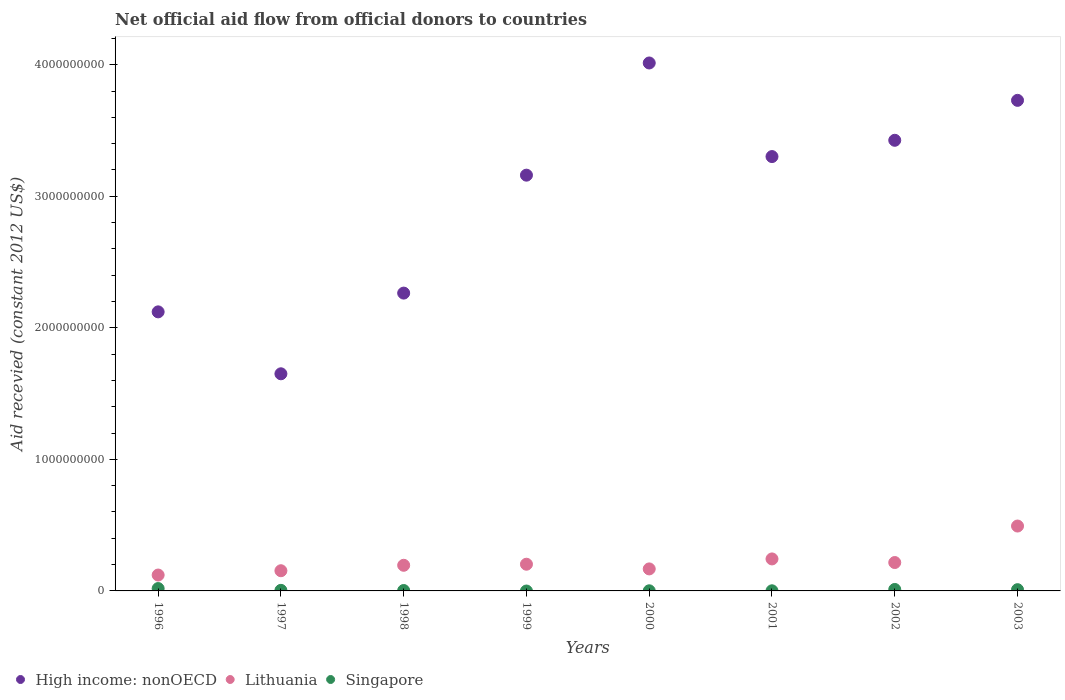Is the number of dotlines equal to the number of legend labels?
Provide a short and direct response. No. What is the total aid received in High income: nonOECD in 1997?
Ensure brevity in your answer.  1.65e+09. Across all years, what is the maximum total aid received in High income: nonOECD?
Your answer should be very brief. 4.01e+09. What is the total total aid received in Singapore in the graph?
Give a very brief answer. 4.79e+07. What is the difference between the total aid received in High income: nonOECD in 2001 and that in 2003?
Keep it short and to the point. -4.27e+08. What is the difference between the total aid received in High income: nonOECD in 2002 and the total aid received in Lithuania in 1996?
Provide a short and direct response. 3.30e+09. What is the average total aid received in High income: nonOECD per year?
Provide a succinct answer. 2.96e+09. In the year 2003, what is the difference between the total aid received in Singapore and total aid received in High income: nonOECD?
Your answer should be compact. -3.72e+09. What is the ratio of the total aid received in Singapore in 1997 to that in 1998?
Provide a succinct answer. 1.44. What is the difference between the highest and the second highest total aid received in Singapore?
Make the answer very short. 6.95e+06. What is the difference between the highest and the lowest total aid received in Singapore?
Keep it short and to the point. 1.80e+07. In how many years, is the total aid received in Singapore greater than the average total aid received in Singapore taken over all years?
Offer a very short reply. 3. Is it the case that in every year, the sum of the total aid received in Singapore and total aid received in Lithuania  is greater than the total aid received in High income: nonOECD?
Provide a short and direct response. No. Does the total aid received in Lithuania monotonically increase over the years?
Make the answer very short. No. Is the total aid received in Singapore strictly greater than the total aid received in Lithuania over the years?
Make the answer very short. No. Is the total aid received in Lithuania strictly less than the total aid received in Singapore over the years?
Provide a succinct answer. No. How many dotlines are there?
Ensure brevity in your answer.  3. How many years are there in the graph?
Offer a terse response. 8. What is the difference between two consecutive major ticks on the Y-axis?
Provide a short and direct response. 1.00e+09. Are the values on the major ticks of Y-axis written in scientific E-notation?
Offer a terse response. No. Does the graph contain grids?
Ensure brevity in your answer.  No. How are the legend labels stacked?
Your answer should be compact. Horizontal. What is the title of the graph?
Keep it short and to the point. Net official aid flow from official donors to countries. Does "Vanuatu" appear as one of the legend labels in the graph?
Offer a very short reply. No. What is the label or title of the X-axis?
Your answer should be compact. Years. What is the label or title of the Y-axis?
Ensure brevity in your answer.  Aid recevied (constant 2012 US$). What is the Aid recevied (constant 2012 US$) in High income: nonOECD in 1996?
Offer a very short reply. 2.12e+09. What is the Aid recevied (constant 2012 US$) in Lithuania in 1996?
Your response must be concise. 1.21e+08. What is the Aid recevied (constant 2012 US$) of Singapore in 1996?
Provide a short and direct response. 1.80e+07. What is the Aid recevied (constant 2012 US$) of High income: nonOECD in 1997?
Keep it short and to the point. 1.65e+09. What is the Aid recevied (constant 2012 US$) of Lithuania in 1997?
Provide a short and direct response. 1.53e+08. What is the Aid recevied (constant 2012 US$) of Singapore in 1997?
Provide a succinct answer. 4.37e+06. What is the Aid recevied (constant 2012 US$) of High income: nonOECD in 1998?
Provide a succinct answer. 2.26e+09. What is the Aid recevied (constant 2012 US$) in Lithuania in 1998?
Keep it short and to the point. 1.95e+08. What is the Aid recevied (constant 2012 US$) of Singapore in 1998?
Ensure brevity in your answer.  3.04e+06. What is the Aid recevied (constant 2012 US$) of High income: nonOECD in 1999?
Keep it short and to the point. 3.16e+09. What is the Aid recevied (constant 2012 US$) in Lithuania in 1999?
Provide a succinct answer. 2.03e+08. What is the Aid recevied (constant 2012 US$) in High income: nonOECD in 2000?
Provide a succinct answer. 4.01e+09. What is the Aid recevied (constant 2012 US$) in Lithuania in 2000?
Ensure brevity in your answer.  1.67e+08. What is the Aid recevied (constant 2012 US$) of Singapore in 2000?
Keep it short and to the point. 9.80e+05. What is the Aid recevied (constant 2012 US$) in High income: nonOECD in 2001?
Your answer should be very brief. 3.30e+09. What is the Aid recevied (constant 2012 US$) of Lithuania in 2001?
Provide a succinct answer. 2.43e+08. What is the Aid recevied (constant 2012 US$) of Singapore in 2001?
Keep it short and to the point. 9.60e+05. What is the Aid recevied (constant 2012 US$) in High income: nonOECD in 2002?
Make the answer very short. 3.43e+09. What is the Aid recevied (constant 2012 US$) in Lithuania in 2002?
Offer a terse response. 2.16e+08. What is the Aid recevied (constant 2012 US$) in Singapore in 2002?
Ensure brevity in your answer.  1.11e+07. What is the Aid recevied (constant 2012 US$) of High income: nonOECD in 2003?
Offer a very short reply. 3.73e+09. What is the Aid recevied (constant 2012 US$) in Lithuania in 2003?
Ensure brevity in your answer.  4.93e+08. What is the Aid recevied (constant 2012 US$) in Singapore in 2003?
Give a very brief answer. 9.44e+06. Across all years, what is the maximum Aid recevied (constant 2012 US$) of High income: nonOECD?
Provide a short and direct response. 4.01e+09. Across all years, what is the maximum Aid recevied (constant 2012 US$) in Lithuania?
Offer a terse response. 4.93e+08. Across all years, what is the maximum Aid recevied (constant 2012 US$) in Singapore?
Give a very brief answer. 1.80e+07. Across all years, what is the minimum Aid recevied (constant 2012 US$) of High income: nonOECD?
Your answer should be compact. 1.65e+09. Across all years, what is the minimum Aid recevied (constant 2012 US$) of Lithuania?
Your answer should be compact. 1.21e+08. What is the total Aid recevied (constant 2012 US$) in High income: nonOECD in the graph?
Give a very brief answer. 2.37e+1. What is the total Aid recevied (constant 2012 US$) of Lithuania in the graph?
Provide a succinct answer. 1.79e+09. What is the total Aid recevied (constant 2012 US$) of Singapore in the graph?
Make the answer very short. 4.79e+07. What is the difference between the Aid recevied (constant 2012 US$) of High income: nonOECD in 1996 and that in 1997?
Offer a very short reply. 4.71e+08. What is the difference between the Aid recevied (constant 2012 US$) in Lithuania in 1996 and that in 1997?
Provide a succinct answer. -3.27e+07. What is the difference between the Aid recevied (constant 2012 US$) of Singapore in 1996 and that in 1997?
Give a very brief answer. 1.36e+07. What is the difference between the Aid recevied (constant 2012 US$) of High income: nonOECD in 1996 and that in 1998?
Provide a short and direct response. -1.43e+08. What is the difference between the Aid recevied (constant 2012 US$) of Lithuania in 1996 and that in 1998?
Your response must be concise. -7.41e+07. What is the difference between the Aid recevied (constant 2012 US$) in Singapore in 1996 and that in 1998?
Make the answer very short. 1.50e+07. What is the difference between the Aid recevied (constant 2012 US$) of High income: nonOECD in 1996 and that in 1999?
Provide a short and direct response. -1.04e+09. What is the difference between the Aid recevied (constant 2012 US$) in Lithuania in 1996 and that in 1999?
Provide a succinct answer. -8.22e+07. What is the difference between the Aid recevied (constant 2012 US$) in High income: nonOECD in 1996 and that in 2000?
Ensure brevity in your answer.  -1.89e+09. What is the difference between the Aid recevied (constant 2012 US$) in Lithuania in 1996 and that in 2000?
Offer a terse response. -4.65e+07. What is the difference between the Aid recevied (constant 2012 US$) of Singapore in 1996 and that in 2000?
Provide a succinct answer. 1.70e+07. What is the difference between the Aid recevied (constant 2012 US$) in High income: nonOECD in 1996 and that in 2001?
Your answer should be very brief. -1.18e+09. What is the difference between the Aid recevied (constant 2012 US$) in Lithuania in 1996 and that in 2001?
Provide a succinct answer. -1.22e+08. What is the difference between the Aid recevied (constant 2012 US$) in Singapore in 1996 and that in 2001?
Keep it short and to the point. 1.71e+07. What is the difference between the Aid recevied (constant 2012 US$) of High income: nonOECD in 1996 and that in 2002?
Provide a succinct answer. -1.30e+09. What is the difference between the Aid recevied (constant 2012 US$) of Lithuania in 1996 and that in 2002?
Make the answer very short. -9.50e+07. What is the difference between the Aid recevied (constant 2012 US$) of Singapore in 1996 and that in 2002?
Your response must be concise. 6.95e+06. What is the difference between the Aid recevied (constant 2012 US$) in High income: nonOECD in 1996 and that in 2003?
Provide a succinct answer. -1.61e+09. What is the difference between the Aid recevied (constant 2012 US$) of Lithuania in 1996 and that in 2003?
Provide a succinct answer. -3.72e+08. What is the difference between the Aid recevied (constant 2012 US$) in Singapore in 1996 and that in 2003?
Offer a very short reply. 8.58e+06. What is the difference between the Aid recevied (constant 2012 US$) in High income: nonOECD in 1997 and that in 1998?
Provide a succinct answer. -6.13e+08. What is the difference between the Aid recevied (constant 2012 US$) of Lithuania in 1997 and that in 1998?
Keep it short and to the point. -4.14e+07. What is the difference between the Aid recevied (constant 2012 US$) of Singapore in 1997 and that in 1998?
Your answer should be very brief. 1.33e+06. What is the difference between the Aid recevied (constant 2012 US$) in High income: nonOECD in 1997 and that in 1999?
Your answer should be compact. -1.51e+09. What is the difference between the Aid recevied (constant 2012 US$) of Lithuania in 1997 and that in 1999?
Ensure brevity in your answer.  -4.95e+07. What is the difference between the Aid recevied (constant 2012 US$) in High income: nonOECD in 1997 and that in 2000?
Your answer should be compact. -2.36e+09. What is the difference between the Aid recevied (constant 2012 US$) of Lithuania in 1997 and that in 2000?
Your answer should be compact. -1.38e+07. What is the difference between the Aid recevied (constant 2012 US$) of Singapore in 1997 and that in 2000?
Your answer should be very brief. 3.39e+06. What is the difference between the Aid recevied (constant 2012 US$) of High income: nonOECD in 1997 and that in 2001?
Your answer should be compact. -1.65e+09. What is the difference between the Aid recevied (constant 2012 US$) in Lithuania in 1997 and that in 2001?
Make the answer very short. -8.98e+07. What is the difference between the Aid recevied (constant 2012 US$) in Singapore in 1997 and that in 2001?
Your response must be concise. 3.41e+06. What is the difference between the Aid recevied (constant 2012 US$) of High income: nonOECD in 1997 and that in 2002?
Give a very brief answer. -1.78e+09. What is the difference between the Aid recevied (constant 2012 US$) of Lithuania in 1997 and that in 2002?
Provide a succinct answer. -6.24e+07. What is the difference between the Aid recevied (constant 2012 US$) of Singapore in 1997 and that in 2002?
Give a very brief answer. -6.70e+06. What is the difference between the Aid recevied (constant 2012 US$) in High income: nonOECD in 1997 and that in 2003?
Provide a short and direct response. -2.08e+09. What is the difference between the Aid recevied (constant 2012 US$) of Lithuania in 1997 and that in 2003?
Offer a terse response. -3.40e+08. What is the difference between the Aid recevied (constant 2012 US$) in Singapore in 1997 and that in 2003?
Your answer should be very brief. -5.07e+06. What is the difference between the Aid recevied (constant 2012 US$) of High income: nonOECD in 1998 and that in 1999?
Your response must be concise. -8.97e+08. What is the difference between the Aid recevied (constant 2012 US$) in Lithuania in 1998 and that in 1999?
Provide a short and direct response. -8.09e+06. What is the difference between the Aid recevied (constant 2012 US$) of High income: nonOECD in 1998 and that in 2000?
Give a very brief answer. -1.75e+09. What is the difference between the Aid recevied (constant 2012 US$) of Lithuania in 1998 and that in 2000?
Make the answer very short. 2.76e+07. What is the difference between the Aid recevied (constant 2012 US$) of Singapore in 1998 and that in 2000?
Offer a very short reply. 2.06e+06. What is the difference between the Aid recevied (constant 2012 US$) of High income: nonOECD in 1998 and that in 2001?
Provide a short and direct response. -1.04e+09. What is the difference between the Aid recevied (constant 2012 US$) of Lithuania in 1998 and that in 2001?
Provide a succinct answer. -4.84e+07. What is the difference between the Aid recevied (constant 2012 US$) of Singapore in 1998 and that in 2001?
Your response must be concise. 2.08e+06. What is the difference between the Aid recevied (constant 2012 US$) of High income: nonOECD in 1998 and that in 2002?
Provide a short and direct response. -1.16e+09. What is the difference between the Aid recevied (constant 2012 US$) of Lithuania in 1998 and that in 2002?
Offer a very short reply. -2.10e+07. What is the difference between the Aid recevied (constant 2012 US$) of Singapore in 1998 and that in 2002?
Offer a very short reply. -8.03e+06. What is the difference between the Aid recevied (constant 2012 US$) in High income: nonOECD in 1998 and that in 2003?
Your response must be concise. -1.47e+09. What is the difference between the Aid recevied (constant 2012 US$) in Lithuania in 1998 and that in 2003?
Your answer should be very brief. -2.98e+08. What is the difference between the Aid recevied (constant 2012 US$) in Singapore in 1998 and that in 2003?
Your response must be concise. -6.40e+06. What is the difference between the Aid recevied (constant 2012 US$) in High income: nonOECD in 1999 and that in 2000?
Offer a terse response. -8.53e+08. What is the difference between the Aid recevied (constant 2012 US$) in Lithuania in 1999 and that in 2000?
Offer a terse response. 3.57e+07. What is the difference between the Aid recevied (constant 2012 US$) of High income: nonOECD in 1999 and that in 2001?
Give a very brief answer. -1.41e+08. What is the difference between the Aid recevied (constant 2012 US$) of Lithuania in 1999 and that in 2001?
Offer a terse response. -4.03e+07. What is the difference between the Aid recevied (constant 2012 US$) of High income: nonOECD in 1999 and that in 2002?
Keep it short and to the point. -2.65e+08. What is the difference between the Aid recevied (constant 2012 US$) in Lithuania in 1999 and that in 2002?
Give a very brief answer. -1.29e+07. What is the difference between the Aid recevied (constant 2012 US$) in High income: nonOECD in 1999 and that in 2003?
Make the answer very short. -5.69e+08. What is the difference between the Aid recevied (constant 2012 US$) of Lithuania in 1999 and that in 2003?
Provide a short and direct response. -2.90e+08. What is the difference between the Aid recevied (constant 2012 US$) of High income: nonOECD in 2000 and that in 2001?
Ensure brevity in your answer.  7.12e+08. What is the difference between the Aid recevied (constant 2012 US$) of Lithuania in 2000 and that in 2001?
Keep it short and to the point. -7.60e+07. What is the difference between the Aid recevied (constant 2012 US$) of Singapore in 2000 and that in 2001?
Provide a short and direct response. 2.00e+04. What is the difference between the Aid recevied (constant 2012 US$) of High income: nonOECD in 2000 and that in 2002?
Provide a succinct answer. 5.88e+08. What is the difference between the Aid recevied (constant 2012 US$) of Lithuania in 2000 and that in 2002?
Offer a very short reply. -4.85e+07. What is the difference between the Aid recevied (constant 2012 US$) in Singapore in 2000 and that in 2002?
Your answer should be compact. -1.01e+07. What is the difference between the Aid recevied (constant 2012 US$) in High income: nonOECD in 2000 and that in 2003?
Give a very brief answer. 2.84e+08. What is the difference between the Aid recevied (constant 2012 US$) in Lithuania in 2000 and that in 2003?
Your answer should be very brief. -3.26e+08. What is the difference between the Aid recevied (constant 2012 US$) in Singapore in 2000 and that in 2003?
Offer a very short reply. -8.46e+06. What is the difference between the Aid recevied (constant 2012 US$) of High income: nonOECD in 2001 and that in 2002?
Your answer should be compact. -1.24e+08. What is the difference between the Aid recevied (constant 2012 US$) of Lithuania in 2001 and that in 2002?
Give a very brief answer. 2.74e+07. What is the difference between the Aid recevied (constant 2012 US$) of Singapore in 2001 and that in 2002?
Provide a succinct answer. -1.01e+07. What is the difference between the Aid recevied (constant 2012 US$) in High income: nonOECD in 2001 and that in 2003?
Make the answer very short. -4.27e+08. What is the difference between the Aid recevied (constant 2012 US$) of Lithuania in 2001 and that in 2003?
Offer a terse response. -2.50e+08. What is the difference between the Aid recevied (constant 2012 US$) of Singapore in 2001 and that in 2003?
Your response must be concise. -8.48e+06. What is the difference between the Aid recevied (constant 2012 US$) in High income: nonOECD in 2002 and that in 2003?
Make the answer very short. -3.04e+08. What is the difference between the Aid recevied (constant 2012 US$) in Lithuania in 2002 and that in 2003?
Give a very brief answer. -2.77e+08. What is the difference between the Aid recevied (constant 2012 US$) of Singapore in 2002 and that in 2003?
Provide a short and direct response. 1.63e+06. What is the difference between the Aid recevied (constant 2012 US$) of High income: nonOECD in 1996 and the Aid recevied (constant 2012 US$) of Lithuania in 1997?
Your answer should be compact. 1.97e+09. What is the difference between the Aid recevied (constant 2012 US$) in High income: nonOECD in 1996 and the Aid recevied (constant 2012 US$) in Singapore in 1997?
Provide a succinct answer. 2.12e+09. What is the difference between the Aid recevied (constant 2012 US$) in Lithuania in 1996 and the Aid recevied (constant 2012 US$) in Singapore in 1997?
Your answer should be very brief. 1.16e+08. What is the difference between the Aid recevied (constant 2012 US$) of High income: nonOECD in 1996 and the Aid recevied (constant 2012 US$) of Lithuania in 1998?
Ensure brevity in your answer.  1.93e+09. What is the difference between the Aid recevied (constant 2012 US$) of High income: nonOECD in 1996 and the Aid recevied (constant 2012 US$) of Singapore in 1998?
Offer a very short reply. 2.12e+09. What is the difference between the Aid recevied (constant 2012 US$) in Lithuania in 1996 and the Aid recevied (constant 2012 US$) in Singapore in 1998?
Provide a short and direct response. 1.18e+08. What is the difference between the Aid recevied (constant 2012 US$) of High income: nonOECD in 1996 and the Aid recevied (constant 2012 US$) of Lithuania in 1999?
Offer a terse response. 1.92e+09. What is the difference between the Aid recevied (constant 2012 US$) of High income: nonOECD in 1996 and the Aid recevied (constant 2012 US$) of Lithuania in 2000?
Keep it short and to the point. 1.95e+09. What is the difference between the Aid recevied (constant 2012 US$) of High income: nonOECD in 1996 and the Aid recevied (constant 2012 US$) of Singapore in 2000?
Offer a terse response. 2.12e+09. What is the difference between the Aid recevied (constant 2012 US$) of Lithuania in 1996 and the Aid recevied (constant 2012 US$) of Singapore in 2000?
Provide a succinct answer. 1.20e+08. What is the difference between the Aid recevied (constant 2012 US$) in High income: nonOECD in 1996 and the Aid recevied (constant 2012 US$) in Lithuania in 2001?
Keep it short and to the point. 1.88e+09. What is the difference between the Aid recevied (constant 2012 US$) in High income: nonOECD in 1996 and the Aid recevied (constant 2012 US$) in Singapore in 2001?
Your response must be concise. 2.12e+09. What is the difference between the Aid recevied (constant 2012 US$) of Lithuania in 1996 and the Aid recevied (constant 2012 US$) of Singapore in 2001?
Your answer should be very brief. 1.20e+08. What is the difference between the Aid recevied (constant 2012 US$) of High income: nonOECD in 1996 and the Aid recevied (constant 2012 US$) of Lithuania in 2002?
Offer a terse response. 1.91e+09. What is the difference between the Aid recevied (constant 2012 US$) of High income: nonOECD in 1996 and the Aid recevied (constant 2012 US$) of Singapore in 2002?
Keep it short and to the point. 2.11e+09. What is the difference between the Aid recevied (constant 2012 US$) in Lithuania in 1996 and the Aid recevied (constant 2012 US$) in Singapore in 2002?
Your response must be concise. 1.10e+08. What is the difference between the Aid recevied (constant 2012 US$) of High income: nonOECD in 1996 and the Aid recevied (constant 2012 US$) of Lithuania in 2003?
Offer a terse response. 1.63e+09. What is the difference between the Aid recevied (constant 2012 US$) of High income: nonOECD in 1996 and the Aid recevied (constant 2012 US$) of Singapore in 2003?
Provide a short and direct response. 2.11e+09. What is the difference between the Aid recevied (constant 2012 US$) of Lithuania in 1996 and the Aid recevied (constant 2012 US$) of Singapore in 2003?
Provide a succinct answer. 1.11e+08. What is the difference between the Aid recevied (constant 2012 US$) of High income: nonOECD in 1997 and the Aid recevied (constant 2012 US$) of Lithuania in 1998?
Your answer should be compact. 1.46e+09. What is the difference between the Aid recevied (constant 2012 US$) in High income: nonOECD in 1997 and the Aid recevied (constant 2012 US$) in Singapore in 1998?
Provide a short and direct response. 1.65e+09. What is the difference between the Aid recevied (constant 2012 US$) in Lithuania in 1997 and the Aid recevied (constant 2012 US$) in Singapore in 1998?
Keep it short and to the point. 1.50e+08. What is the difference between the Aid recevied (constant 2012 US$) in High income: nonOECD in 1997 and the Aid recevied (constant 2012 US$) in Lithuania in 1999?
Your answer should be compact. 1.45e+09. What is the difference between the Aid recevied (constant 2012 US$) in High income: nonOECD in 1997 and the Aid recevied (constant 2012 US$) in Lithuania in 2000?
Your answer should be compact. 1.48e+09. What is the difference between the Aid recevied (constant 2012 US$) of High income: nonOECD in 1997 and the Aid recevied (constant 2012 US$) of Singapore in 2000?
Keep it short and to the point. 1.65e+09. What is the difference between the Aid recevied (constant 2012 US$) of Lithuania in 1997 and the Aid recevied (constant 2012 US$) of Singapore in 2000?
Make the answer very short. 1.52e+08. What is the difference between the Aid recevied (constant 2012 US$) of High income: nonOECD in 1997 and the Aid recevied (constant 2012 US$) of Lithuania in 2001?
Offer a very short reply. 1.41e+09. What is the difference between the Aid recevied (constant 2012 US$) in High income: nonOECD in 1997 and the Aid recevied (constant 2012 US$) in Singapore in 2001?
Provide a short and direct response. 1.65e+09. What is the difference between the Aid recevied (constant 2012 US$) in Lithuania in 1997 and the Aid recevied (constant 2012 US$) in Singapore in 2001?
Give a very brief answer. 1.52e+08. What is the difference between the Aid recevied (constant 2012 US$) of High income: nonOECD in 1997 and the Aid recevied (constant 2012 US$) of Lithuania in 2002?
Give a very brief answer. 1.43e+09. What is the difference between the Aid recevied (constant 2012 US$) in High income: nonOECD in 1997 and the Aid recevied (constant 2012 US$) in Singapore in 2002?
Make the answer very short. 1.64e+09. What is the difference between the Aid recevied (constant 2012 US$) of Lithuania in 1997 and the Aid recevied (constant 2012 US$) of Singapore in 2002?
Provide a succinct answer. 1.42e+08. What is the difference between the Aid recevied (constant 2012 US$) of High income: nonOECD in 1997 and the Aid recevied (constant 2012 US$) of Lithuania in 2003?
Offer a very short reply. 1.16e+09. What is the difference between the Aid recevied (constant 2012 US$) in High income: nonOECD in 1997 and the Aid recevied (constant 2012 US$) in Singapore in 2003?
Ensure brevity in your answer.  1.64e+09. What is the difference between the Aid recevied (constant 2012 US$) of Lithuania in 1997 and the Aid recevied (constant 2012 US$) of Singapore in 2003?
Your answer should be very brief. 1.44e+08. What is the difference between the Aid recevied (constant 2012 US$) in High income: nonOECD in 1998 and the Aid recevied (constant 2012 US$) in Lithuania in 1999?
Keep it short and to the point. 2.06e+09. What is the difference between the Aid recevied (constant 2012 US$) of High income: nonOECD in 1998 and the Aid recevied (constant 2012 US$) of Lithuania in 2000?
Make the answer very short. 2.10e+09. What is the difference between the Aid recevied (constant 2012 US$) in High income: nonOECD in 1998 and the Aid recevied (constant 2012 US$) in Singapore in 2000?
Keep it short and to the point. 2.26e+09. What is the difference between the Aid recevied (constant 2012 US$) of Lithuania in 1998 and the Aid recevied (constant 2012 US$) of Singapore in 2000?
Offer a terse response. 1.94e+08. What is the difference between the Aid recevied (constant 2012 US$) in High income: nonOECD in 1998 and the Aid recevied (constant 2012 US$) in Lithuania in 2001?
Give a very brief answer. 2.02e+09. What is the difference between the Aid recevied (constant 2012 US$) in High income: nonOECD in 1998 and the Aid recevied (constant 2012 US$) in Singapore in 2001?
Keep it short and to the point. 2.26e+09. What is the difference between the Aid recevied (constant 2012 US$) in Lithuania in 1998 and the Aid recevied (constant 2012 US$) in Singapore in 2001?
Give a very brief answer. 1.94e+08. What is the difference between the Aid recevied (constant 2012 US$) in High income: nonOECD in 1998 and the Aid recevied (constant 2012 US$) in Lithuania in 2002?
Your answer should be very brief. 2.05e+09. What is the difference between the Aid recevied (constant 2012 US$) of High income: nonOECD in 1998 and the Aid recevied (constant 2012 US$) of Singapore in 2002?
Provide a short and direct response. 2.25e+09. What is the difference between the Aid recevied (constant 2012 US$) in Lithuania in 1998 and the Aid recevied (constant 2012 US$) in Singapore in 2002?
Your response must be concise. 1.84e+08. What is the difference between the Aid recevied (constant 2012 US$) in High income: nonOECD in 1998 and the Aid recevied (constant 2012 US$) in Lithuania in 2003?
Provide a short and direct response. 1.77e+09. What is the difference between the Aid recevied (constant 2012 US$) in High income: nonOECD in 1998 and the Aid recevied (constant 2012 US$) in Singapore in 2003?
Give a very brief answer. 2.25e+09. What is the difference between the Aid recevied (constant 2012 US$) in Lithuania in 1998 and the Aid recevied (constant 2012 US$) in Singapore in 2003?
Offer a very short reply. 1.85e+08. What is the difference between the Aid recevied (constant 2012 US$) of High income: nonOECD in 1999 and the Aid recevied (constant 2012 US$) of Lithuania in 2000?
Your answer should be compact. 2.99e+09. What is the difference between the Aid recevied (constant 2012 US$) in High income: nonOECD in 1999 and the Aid recevied (constant 2012 US$) in Singapore in 2000?
Ensure brevity in your answer.  3.16e+09. What is the difference between the Aid recevied (constant 2012 US$) of Lithuania in 1999 and the Aid recevied (constant 2012 US$) of Singapore in 2000?
Make the answer very short. 2.02e+08. What is the difference between the Aid recevied (constant 2012 US$) of High income: nonOECD in 1999 and the Aid recevied (constant 2012 US$) of Lithuania in 2001?
Ensure brevity in your answer.  2.92e+09. What is the difference between the Aid recevied (constant 2012 US$) in High income: nonOECD in 1999 and the Aid recevied (constant 2012 US$) in Singapore in 2001?
Give a very brief answer. 3.16e+09. What is the difference between the Aid recevied (constant 2012 US$) in Lithuania in 1999 and the Aid recevied (constant 2012 US$) in Singapore in 2001?
Your response must be concise. 2.02e+08. What is the difference between the Aid recevied (constant 2012 US$) in High income: nonOECD in 1999 and the Aid recevied (constant 2012 US$) in Lithuania in 2002?
Keep it short and to the point. 2.94e+09. What is the difference between the Aid recevied (constant 2012 US$) in High income: nonOECD in 1999 and the Aid recevied (constant 2012 US$) in Singapore in 2002?
Your answer should be very brief. 3.15e+09. What is the difference between the Aid recevied (constant 2012 US$) in Lithuania in 1999 and the Aid recevied (constant 2012 US$) in Singapore in 2002?
Ensure brevity in your answer.  1.92e+08. What is the difference between the Aid recevied (constant 2012 US$) in High income: nonOECD in 1999 and the Aid recevied (constant 2012 US$) in Lithuania in 2003?
Keep it short and to the point. 2.67e+09. What is the difference between the Aid recevied (constant 2012 US$) of High income: nonOECD in 1999 and the Aid recevied (constant 2012 US$) of Singapore in 2003?
Offer a terse response. 3.15e+09. What is the difference between the Aid recevied (constant 2012 US$) in Lithuania in 1999 and the Aid recevied (constant 2012 US$) in Singapore in 2003?
Give a very brief answer. 1.94e+08. What is the difference between the Aid recevied (constant 2012 US$) of High income: nonOECD in 2000 and the Aid recevied (constant 2012 US$) of Lithuania in 2001?
Give a very brief answer. 3.77e+09. What is the difference between the Aid recevied (constant 2012 US$) of High income: nonOECD in 2000 and the Aid recevied (constant 2012 US$) of Singapore in 2001?
Your answer should be compact. 4.01e+09. What is the difference between the Aid recevied (constant 2012 US$) in Lithuania in 2000 and the Aid recevied (constant 2012 US$) in Singapore in 2001?
Offer a very short reply. 1.66e+08. What is the difference between the Aid recevied (constant 2012 US$) in High income: nonOECD in 2000 and the Aid recevied (constant 2012 US$) in Lithuania in 2002?
Make the answer very short. 3.80e+09. What is the difference between the Aid recevied (constant 2012 US$) of High income: nonOECD in 2000 and the Aid recevied (constant 2012 US$) of Singapore in 2002?
Offer a terse response. 4.00e+09. What is the difference between the Aid recevied (constant 2012 US$) in Lithuania in 2000 and the Aid recevied (constant 2012 US$) in Singapore in 2002?
Give a very brief answer. 1.56e+08. What is the difference between the Aid recevied (constant 2012 US$) in High income: nonOECD in 2000 and the Aid recevied (constant 2012 US$) in Lithuania in 2003?
Make the answer very short. 3.52e+09. What is the difference between the Aid recevied (constant 2012 US$) in High income: nonOECD in 2000 and the Aid recevied (constant 2012 US$) in Singapore in 2003?
Your response must be concise. 4.00e+09. What is the difference between the Aid recevied (constant 2012 US$) in Lithuania in 2000 and the Aid recevied (constant 2012 US$) in Singapore in 2003?
Your answer should be very brief. 1.58e+08. What is the difference between the Aid recevied (constant 2012 US$) in High income: nonOECD in 2001 and the Aid recevied (constant 2012 US$) in Lithuania in 2002?
Provide a short and direct response. 3.09e+09. What is the difference between the Aid recevied (constant 2012 US$) of High income: nonOECD in 2001 and the Aid recevied (constant 2012 US$) of Singapore in 2002?
Ensure brevity in your answer.  3.29e+09. What is the difference between the Aid recevied (constant 2012 US$) of Lithuania in 2001 and the Aid recevied (constant 2012 US$) of Singapore in 2002?
Your response must be concise. 2.32e+08. What is the difference between the Aid recevied (constant 2012 US$) of High income: nonOECD in 2001 and the Aid recevied (constant 2012 US$) of Lithuania in 2003?
Your response must be concise. 2.81e+09. What is the difference between the Aid recevied (constant 2012 US$) in High income: nonOECD in 2001 and the Aid recevied (constant 2012 US$) in Singapore in 2003?
Make the answer very short. 3.29e+09. What is the difference between the Aid recevied (constant 2012 US$) in Lithuania in 2001 and the Aid recevied (constant 2012 US$) in Singapore in 2003?
Your response must be concise. 2.34e+08. What is the difference between the Aid recevied (constant 2012 US$) in High income: nonOECD in 2002 and the Aid recevied (constant 2012 US$) in Lithuania in 2003?
Offer a very short reply. 2.93e+09. What is the difference between the Aid recevied (constant 2012 US$) of High income: nonOECD in 2002 and the Aid recevied (constant 2012 US$) of Singapore in 2003?
Your answer should be very brief. 3.42e+09. What is the difference between the Aid recevied (constant 2012 US$) of Lithuania in 2002 and the Aid recevied (constant 2012 US$) of Singapore in 2003?
Make the answer very short. 2.06e+08. What is the average Aid recevied (constant 2012 US$) of High income: nonOECD per year?
Ensure brevity in your answer.  2.96e+09. What is the average Aid recevied (constant 2012 US$) of Lithuania per year?
Your response must be concise. 2.24e+08. What is the average Aid recevied (constant 2012 US$) of Singapore per year?
Give a very brief answer. 5.98e+06. In the year 1996, what is the difference between the Aid recevied (constant 2012 US$) of High income: nonOECD and Aid recevied (constant 2012 US$) of Lithuania?
Make the answer very short. 2.00e+09. In the year 1996, what is the difference between the Aid recevied (constant 2012 US$) of High income: nonOECD and Aid recevied (constant 2012 US$) of Singapore?
Offer a very short reply. 2.10e+09. In the year 1996, what is the difference between the Aid recevied (constant 2012 US$) of Lithuania and Aid recevied (constant 2012 US$) of Singapore?
Make the answer very short. 1.03e+08. In the year 1997, what is the difference between the Aid recevied (constant 2012 US$) of High income: nonOECD and Aid recevied (constant 2012 US$) of Lithuania?
Provide a short and direct response. 1.50e+09. In the year 1997, what is the difference between the Aid recevied (constant 2012 US$) of High income: nonOECD and Aid recevied (constant 2012 US$) of Singapore?
Provide a succinct answer. 1.65e+09. In the year 1997, what is the difference between the Aid recevied (constant 2012 US$) in Lithuania and Aid recevied (constant 2012 US$) in Singapore?
Make the answer very short. 1.49e+08. In the year 1998, what is the difference between the Aid recevied (constant 2012 US$) of High income: nonOECD and Aid recevied (constant 2012 US$) of Lithuania?
Provide a short and direct response. 2.07e+09. In the year 1998, what is the difference between the Aid recevied (constant 2012 US$) of High income: nonOECD and Aid recevied (constant 2012 US$) of Singapore?
Ensure brevity in your answer.  2.26e+09. In the year 1998, what is the difference between the Aid recevied (constant 2012 US$) in Lithuania and Aid recevied (constant 2012 US$) in Singapore?
Your answer should be very brief. 1.92e+08. In the year 1999, what is the difference between the Aid recevied (constant 2012 US$) of High income: nonOECD and Aid recevied (constant 2012 US$) of Lithuania?
Your response must be concise. 2.96e+09. In the year 2000, what is the difference between the Aid recevied (constant 2012 US$) in High income: nonOECD and Aid recevied (constant 2012 US$) in Lithuania?
Provide a short and direct response. 3.85e+09. In the year 2000, what is the difference between the Aid recevied (constant 2012 US$) in High income: nonOECD and Aid recevied (constant 2012 US$) in Singapore?
Your response must be concise. 4.01e+09. In the year 2000, what is the difference between the Aid recevied (constant 2012 US$) in Lithuania and Aid recevied (constant 2012 US$) in Singapore?
Keep it short and to the point. 1.66e+08. In the year 2001, what is the difference between the Aid recevied (constant 2012 US$) in High income: nonOECD and Aid recevied (constant 2012 US$) in Lithuania?
Keep it short and to the point. 3.06e+09. In the year 2001, what is the difference between the Aid recevied (constant 2012 US$) of High income: nonOECD and Aid recevied (constant 2012 US$) of Singapore?
Make the answer very short. 3.30e+09. In the year 2001, what is the difference between the Aid recevied (constant 2012 US$) of Lithuania and Aid recevied (constant 2012 US$) of Singapore?
Keep it short and to the point. 2.42e+08. In the year 2002, what is the difference between the Aid recevied (constant 2012 US$) of High income: nonOECD and Aid recevied (constant 2012 US$) of Lithuania?
Your answer should be compact. 3.21e+09. In the year 2002, what is the difference between the Aid recevied (constant 2012 US$) in High income: nonOECD and Aid recevied (constant 2012 US$) in Singapore?
Provide a succinct answer. 3.41e+09. In the year 2002, what is the difference between the Aid recevied (constant 2012 US$) of Lithuania and Aid recevied (constant 2012 US$) of Singapore?
Provide a short and direct response. 2.05e+08. In the year 2003, what is the difference between the Aid recevied (constant 2012 US$) in High income: nonOECD and Aid recevied (constant 2012 US$) in Lithuania?
Your answer should be very brief. 3.24e+09. In the year 2003, what is the difference between the Aid recevied (constant 2012 US$) of High income: nonOECD and Aid recevied (constant 2012 US$) of Singapore?
Provide a short and direct response. 3.72e+09. In the year 2003, what is the difference between the Aid recevied (constant 2012 US$) in Lithuania and Aid recevied (constant 2012 US$) in Singapore?
Provide a succinct answer. 4.84e+08. What is the ratio of the Aid recevied (constant 2012 US$) in High income: nonOECD in 1996 to that in 1997?
Keep it short and to the point. 1.29. What is the ratio of the Aid recevied (constant 2012 US$) in Lithuania in 1996 to that in 1997?
Your answer should be compact. 0.79. What is the ratio of the Aid recevied (constant 2012 US$) in Singapore in 1996 to that in 1997?
Your answer should be compact. 4.12. What is the ratio of the Aid recevied (constant 2012 US$) of High income: nonOECD in 1996 to that in 1998?
Provide a succinct answer. 0.94. What is the ratio of the Aid recevied (constant 2012 US$) of Lithuania in 1996 to that in 1998?
Keep it short and to the point. 0.62. What is the ratio of the Aid recevied (constant 2012 US$) in Singapore in 1996 to that in 1998?
Your answer should be very brief. 5.93. What is the ratio of the Aid recevied (constant 2012 US$) of High income: nonOECD in 1996 to that in 1999?
Your answer should be compact. 0.67. What is the ratio of the Aid recevied (constant 2012 US$) of Lithuania in 1996 to that in 1999?
Your answer should be compact. 0.6. What is the ratio of the Aid recevied (constant 2012 US$) in High income: nonOECD in 1996 to that in 2000?
Provide a short and direct response. 0.53. What is the ratio of the Aid recevied (constant 2012 US$) in Lithuania in 1996 to that in 2000?
Provide a succinct answer. 0.72. What is the ratio of the Aid recevied (constant 2012 US$) in Singapore in 1996 to that in 2000?
Give a very brief answer. 18.39. What is the ratio of the Aid recevied (constant 2012 US$) of High income: nonOECD in 1996 to that in 2001?
Keep it short and to the point. 0.64. What is the ratio of the Aid recevied (constant 2012 US$) in Lithuania in 1996 to that in 2001?
Make the answer very short. 0.5. What is the ratio of the Aid recevied (constant 2012 US$) in Singapore in 1996 to that in 2001?
Your response must be concise. 18.77. What is the ratio of the Aid recevied (constant 2012 US$) in High income: nonOECD in 1996 to that in 2002?
Provide a short and direct response. 0.62. What is the ratio of the Aid recevied (constant 2012 US$) of Lithuania in 1996 to that in 2002?
Offer a very short reply. 0.56. What is the ratio of the Aid recevied (constant 2012 US$) of Singapore in 1996 to that in 2002?
Offer a very short reply. 1.63. What is the ratio of the Aid recevied (constant 2012 US$) in High income: nonOECD in 1996 to that in 2003?
Provide a succinct answer. 0.57. What is the ratio of the Aid recevied (constant 2012 US$) of Lithuania in 1996 to that in 2003?
Keep it short and to the point. 0.24. What is the ratio of the Aid recevied (constant 2012 US$) in Singapore in 1996 to that in 2003?
Make the answer very short. 1.91. What is the ratio of the Aid recevied (constant 2012 US$) in High income: nonOECD in 1997 to that in 1998?
Provide a succinct answer. 0.73. What is the ratio of the Aid recevied (constant 2012 US$) of Lithuania in 1997 to that in 1998?
Your answer should be very brief. 0.79. What is the ratio of the Aid recevied (constant 2012 US$) in Singapore in 1997 to that in 1998?
Offer a very short reply. 1.44. What is the ratio of the Aid recevied (constant 2012 US$) of High income: nonOECD in 1997 to that in 1999?
Your answer should be compact. 0.52. What is the ratio of the Aid recevied (constant 2012 US$) of Lithuania in 1997 to that in 1999?
Your response must be concise. 0.76. What is the ratio of the Aid recevied (constant 2012 US$) of High income: nonOECD in 1997 to that in 2000?
Make the answer very short. 0.41. What is the ratio of the Aid recevied (constant 2012 US$) of Lithuania in 1997 to that in 2000?
Give a very brief answer. 0.92. What is the ratio of the Aid recevied (constant 2012 US$) in Singapore in 1997 to that in 2000?
Your response must be concise. 4.46. What is the ratio of the Aid recevied (constant 2012 US$) of High income: nonOECD in 1997 to that in 2001?
Make the answer very short. 0.5. What is the ratio of the Aid recevied (constant 2012 US$) in Lithuania in 1997 to that in 2001?
Make the answer very short. 0.63. What is the ratio of the Aid recevied (constant 2012 US$) of Singapore in 1997 to that in 2001?
Give a very brief answer. 4.55. What is the ratio of the Aid recevied (constant 2012 US$) of High income: nonOECD in 1997 to that in 2002?
Keep it short and to the point. 0.48. What is the ratio of the Aid recevied (constant 2012 US$) in Lithuania in 1997 to that in 2002?
Provide a short and direct response. 0.71. What is the ratio of the Aid recevied (constant 2012 US$) of Singapore in 1997 to that in 2002?
Your answer should be very brief. 0.39. What is the ratio of the Aid recevied (constant 2012 US$) in High income: nonOECD in 1997 to that in 2003?
Your answer should be compact. 0.44. What is the ratio of the Aid recevied (constant 2012 US$) in Lithuania in 1997 to that in 2003?
Your response must be concise. 0.31. What is the ratio of the Aid recevied (constant 2012 US$) in Singapore in 1997 to that in 2003?
Ensure brevity in your answer.  0.46. What is the ratio of the Aid recevied (constant 2012 US$) in High income: nonOECD in 1998 to that in 1999?
Offer a very short reply. 0.72. What is the ratio of the Aid recevied (constant 2012 US$) of Lithuania in 1998 to that in 1999?
Ensure brevity in your answer.  0.96. What is the ratio of the Aid recevied (constant 2012 US$) of High income: nonOECD in 1998 to that in 2000?
Keep it short and to the point. 0.56. What is the ratio of the Aid recevied (constant 2012 US$) in Lithuania in 1998 to that in 2000?
Provide a succinct answer. 1.16. What is the ratio of the Aid recevied (constant 2012 US$) in Singapore in 1998 to that in 2000?
Your answer should be very brief. 3.1. What is the ratio of the Aid recevied (constant 2012 US$) in High income: nonOECD in 1998 to that in 2001?
Your response must be concise. 0.69. What is the ratio of the Aid recevied (constant 2012 US$) in Lithuania in 1998 to that in 2001?
Your answer should be very brief. 0.8. What is the ratio of the Aid recevied (constant 2012 US$) in Singapore in 1998 to that in 2001?
Make the answer very short. 3.17. What is the ratio of the Aid recevied (constant 2012 US$) of High income: nonOECD in 1998 to that in 2002?
Your answer should be compact. 0.66. What is the ratio of the Aid recevied (constant 2012 US$) of Lithuania in 1998 to that in 2002?
Your response must be concise. 0.9. What is the ratio of the Aid recevied (constant 2012 US$) of Singapore in 1998 to that in 2002?
Offer a very short reply. 0.27. What is the ratio of the Aid recevied (constant 2012 US$) in High income: nonOECD in 1998 to that in 2003?
Make the answer very short. 0.61. What is the ratio of the Aid recevied (constant 2012 US$) of Lithuania in 1998 to that in 2003?
Your response must be concise. 0.4. What is the ratio of the Aid recevied (constant 2012 US$) in Singapore in 1998 to that in 2003?
Keep it short and to the point. 0.32. What is the ratio of the Aid recevied (constant 2012 US$) of High income: nonOECD in 1999 to that in 2000?
Offer a very short reply. 0.79. What is the ratio of the Aid recevied (constant 2012 US$) of Lithuania in 1999 to that in 2000?
Offer a very short reply. 1.21. What is the ratio of the Aid recevied (constant 2012 US$) in High income: nonOECD in 1999 to that in 2001?
Provide a short and direct response. 0.96. What is the ratio of the Aid recevied (constant 2012 US$) of Lithuania in 1999 to that in 2001?
Ensure brevity in your answer.  0.83. What is the ratio of the Aid recevied (constant 2012 US$) of High income: nonOECD in 1999 to that in 2002?
Offer a very short reply. 0.92. What is the ratio of the Aid recevied (constant 2012 US$) in Lithuania in 1999 to that in 2002?
Offer a terse response. 0.94. What is the ratio of the Aid recevied (constant 2012 US$) in High income: nonOECD in 1999 to that in 2003?
Make the answer very short. 0.85. What is the ratio of the Aid recevied (constant 2012 US$) in Lithuania in 1999 to that in 2003?
Provide a succinct answer. 0.41. What is the ratio of the Aid recevied (constant 2012 US$) of High income: nonOECD in 2000 to that in 2001?
Your answer should be compact. 1.22. What is the ratio of the Aid recevied (constant 2012 US$) in Lithuania in 2000 to that in 2001?
Offer a terse response. 0.69. What is the ratio of the Aid recevied (constant 2012 US$) in Singapore in 2000 to that in 2001?
Give a very brief answer. 1.02. What is the ratio of the Aid recevied (constant 2012 US$) in High income: nonOECD in 2000 to that in 2002?
Offer a terse response. 1.17. What is the ratio of the Aid recevied (constant 2012 US$) in Lithuania in 2000 to that in 2002?
Your answer should be compact. 0.78. What is the ratio of the Aid recevied (constant 2012 US$) in Singapore in 2000 to that in 2002?
Give a very brief answer. 0.09. What is the ratio of the Aid recevied (constant 2012 US$) of High income: nonOECD in 2000 to that in 2003?
Provide a succinct answer. 1.08. What is the ratio of the Aid recevied (constant 2012 US$) of Lithuania in 2000 to that in 2003?
Your response must be concise. 0.34. What is the ratio of the Aid recevied (constant 2012 US$) in Singapore in 2000 to that in 2003?
Make the answer very short. 0.1. What is the ratio of the Aid recevied (constant 2012 US$) of High income: nonOECD in 2001 to that in 2002?
Offer a terse response. 0.96. What is the ratio of the Aid recevied (constant 2012 US$) of Lithuania in 2001 to that in 2002?
Give a very brief answer. 1.13. What is the ratio of the Aid recevied (constant 2012 US$) in Singapore in 2001 to that in 2002?
Provide a short and direct response. 0.09. What is the ratio of the Aid recevied (constant 2012 US$) of High income: nonOECD in 2001 to that in 2003?
Provide a short and direct response. 0.89. What is the ratio of the Aid recevied (constant 2012 US$) of Lithuania in 2001 to that in 2003?
Your answer should be compact. 0.49. What is the ratio of the Aid recevied (constant 2012 US$) in Singapore in 2001 to that in 2003?
Your answer should be very brief. 0.1. What is the ratio of the Aid recevied (constant 2012 US$) of High income: nonOECD in 2002 to that in 2003?
Give a very brief answer. 0.92. What is the ratio of the Aid recevied (constant 2012 US$) in Lithuania in 2002 to that in 2003?
Keep it short and to the point. 0.44. What is the ratio of the Aid recevied (constant 2012 US$) of Singapore in 2002 to that in 2003?
Your answer should be very brief. 1.17. What is the difference between the highest and the second highest Aid recevied (constant 2012 US$) in High income: nonOECD?
Your answer should be very brief. 2.84e+08. What is the difference between the highest and the second highest Aid recevied (constant 2012 US$) of Lithuania?
Ensure brevity in your answer.  2.50e+08. What is the difference between the highest and the second highest Aid recevied (constant 2012 US$) in Singapore?
Offer a very short reply. 6.95e+06. What is the difference between the highest and the lowest Aid recevied (constant 2012 US$) in High income: nonOECD?
Offer a very short reply. 2.36e+09. What is the difference between the highest and the lowest Aid recevied (constant 2012 US$) of Lithuania?
Keep it short and to the point. 3.72e+08. What is the difference between the highest and the lowest Aid recevied (constant 2012 US$) in Singapore?
Ensure brevity in your answer.  1.80e+07. 